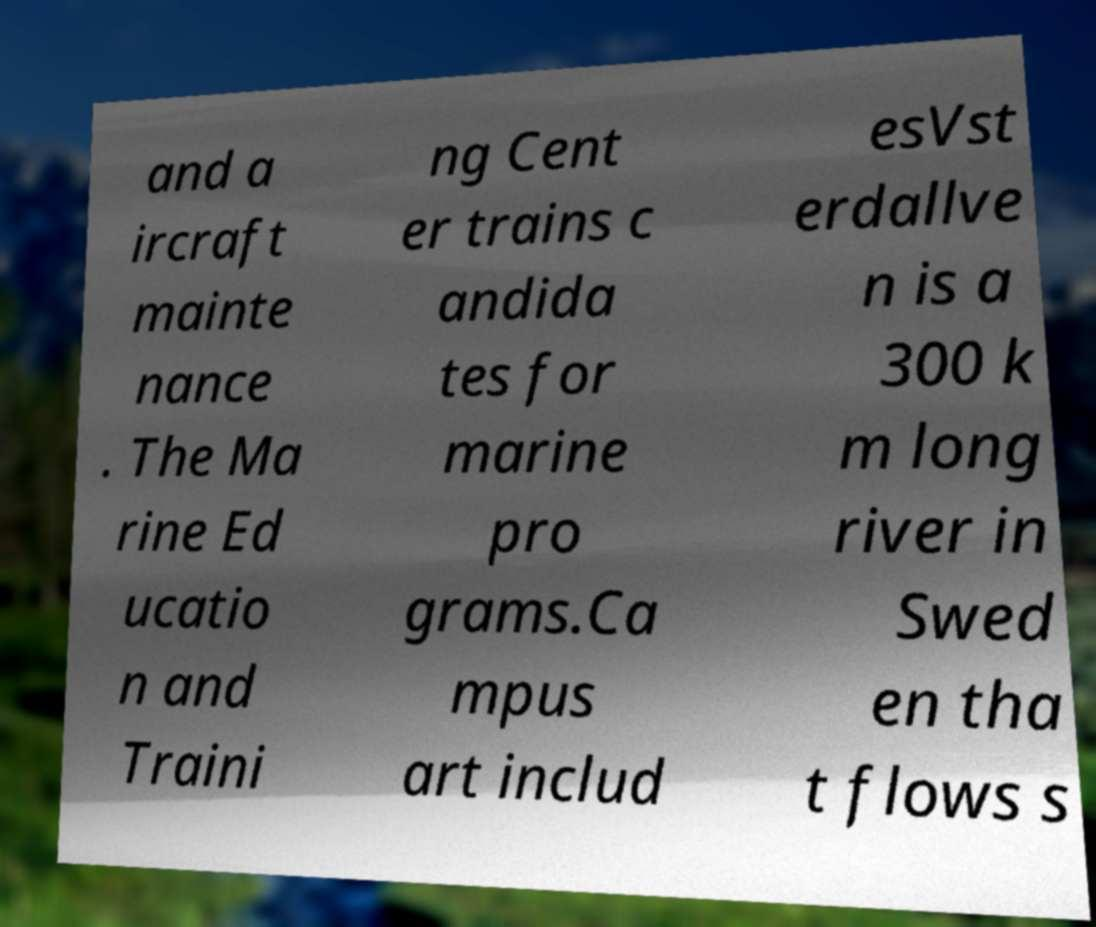Please read and relay the text visible in this image. What does it say? and a ircraft mainte nance . The Ma rine Ed ucatio n and Traini ng Cent er trains c andida tes for marine pro grams.Ca mpus art includ esVst erdallve n is a 300 k m long river in Swed en tha t flows s 